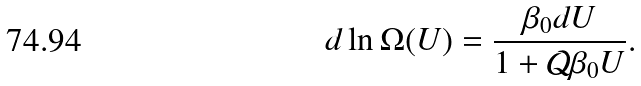<formula> <loc_0><loc_0><loc_500><loc_500>d \ln \Omega ( U ) = \frac { \beta _ { 0 } d U } { 1 + { \mathcal { Q } } \beta _ { 0 } U } .</formula> 